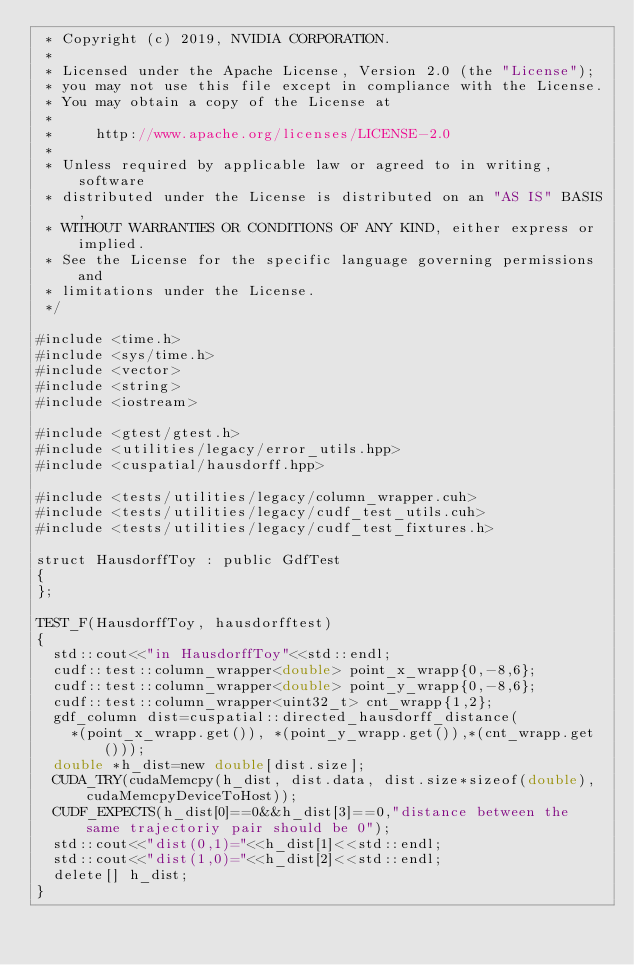Convert code to text. <code><loc_0><loc_0><loc_500><loc_500><_Cuda_> * Copyright (c) 2019, NVIDIA CORPORATION.
 *
 * Licensed under the Apache License, Version 2.0 (the "License");
 * you may not use this file except in compliance with the License.
 * You may obtain a copy of the License at
 *
 *     http://www.apache.org/licenses/LICENSE-2.0
 *
 * Unless required by applicable law or agreed to in writing, software
 * distributed under the License is distributed on an "AS IS" BASIS,
 * WITHOUT WARRANTIES OR CONDITIONS OF ANY KIND, either express or implied.
 * See the License for the specific language governing permissions and
 * limitations under the License.
 */

#include <time.h>
#include <sys/time.h>
#include <vector>
#include <string>
#include <iostream>

#include <gtest/gtest.h>
#include <utilities/legacy/error_utils.hpp>
#include <cuspatial/hausdorff.hpp> 

#include <tests/utilities/legacy/column_wrapper.cuh>
#include <tests/utilities/legacy/cudf_test_utils.cuh>
#include <tests/utilities/legacy/cudf_test_fixtures.h>

struct HausdorffToy : public GdfTest 
{
};   
   
TEST_F(HausdorffToy, hausdorfftest)
{
  std::cout<<"in HausdorffToy"<<std::endl;
  cudf::test::column_wrapper<double> point_x_wrapp{0,-8,6};
  cudf::test::column_wrapper<double> point_y_wrapp{0,-8,6};
  cudf::test::column_wrapper<uint32_t> cnt_wrapp{1,2};
  gdf_column dist=cuspatial::directed_hausdorff_distance(
  	*(point_x_wrapp.get()), *(point_y_wrapp.get()),*(cnt_wrapp.get()));
  double *h_dist=new double[dist.size];
  CUDA_TRY(cudaMemcpy(h_dist, dist.data, dist.size*sizeof(double), cudaMemcpyDeviceToHost));
  CUDF_EXPECTS(h_dist[0]==0&&h_dist[3]==0,"distance between the same trajectoriy pair should be 0"); 
  std::cout<<"dist(0,1)="<<h_dist[1]<<std::endl;
  std::cout<<"dist(1,0)="<<h_dist[2]<<std::endl;
  delete[] h_dist;
}
</code> 